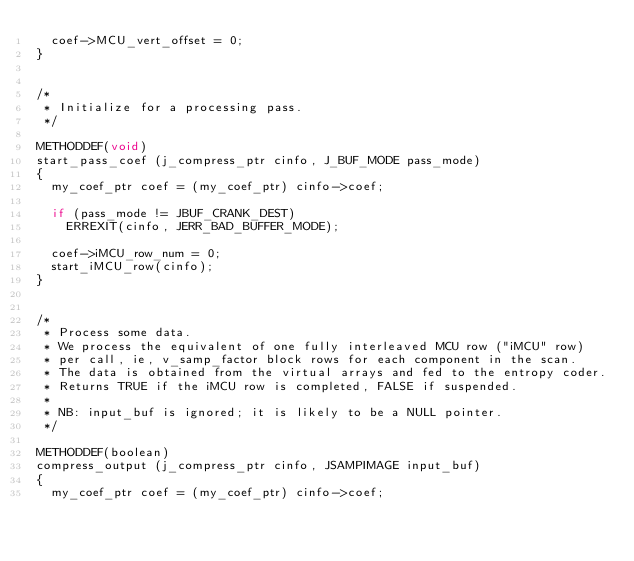<code> <loc_0><loc_0><loc_500><loc_500><_C_>  coef->MCU_vert_offset = 0;
}


/*
 * Initialize for a processing pass.
 */

METHODDEF(void)
start_pass_coef (j_compress_ptr cinfo, J_BUF_MODE pass_mode)
{
  my_coef_ptr coef = (my_coef_ptr) cinfo->coef;

  if (pass_mode != JBUF_CRANK_DEST)
    ERREXIT(cinfo, JERR_BAD_BUFFER_MODE);

  coef->iMCU_row_num = 0;
  start_iMCU_row(cinfo);
}


/*
 * Process some data.
 * We process the equivalent of one fully interleaved MCU row ("iMCU" row)
 * per call, ie, v_samp_factor block rows for each component in the scan.
 * The data is obtained from the virtual arrays and fed to the entropy coder.
 * Returns TRUE if the iMCU row is completed, FALSE if suspended.
 *
 * NB: input_buf is ignored; it is likely to be a NULL pointer.
 */

METHODDEF(boolean)
compress_output (j_compress_ptr cinfo, JSAMPIMAGE input_buf)
{
  my_coef_ptr coef = (my_coef_ptr) cinfo->coef;</code> 